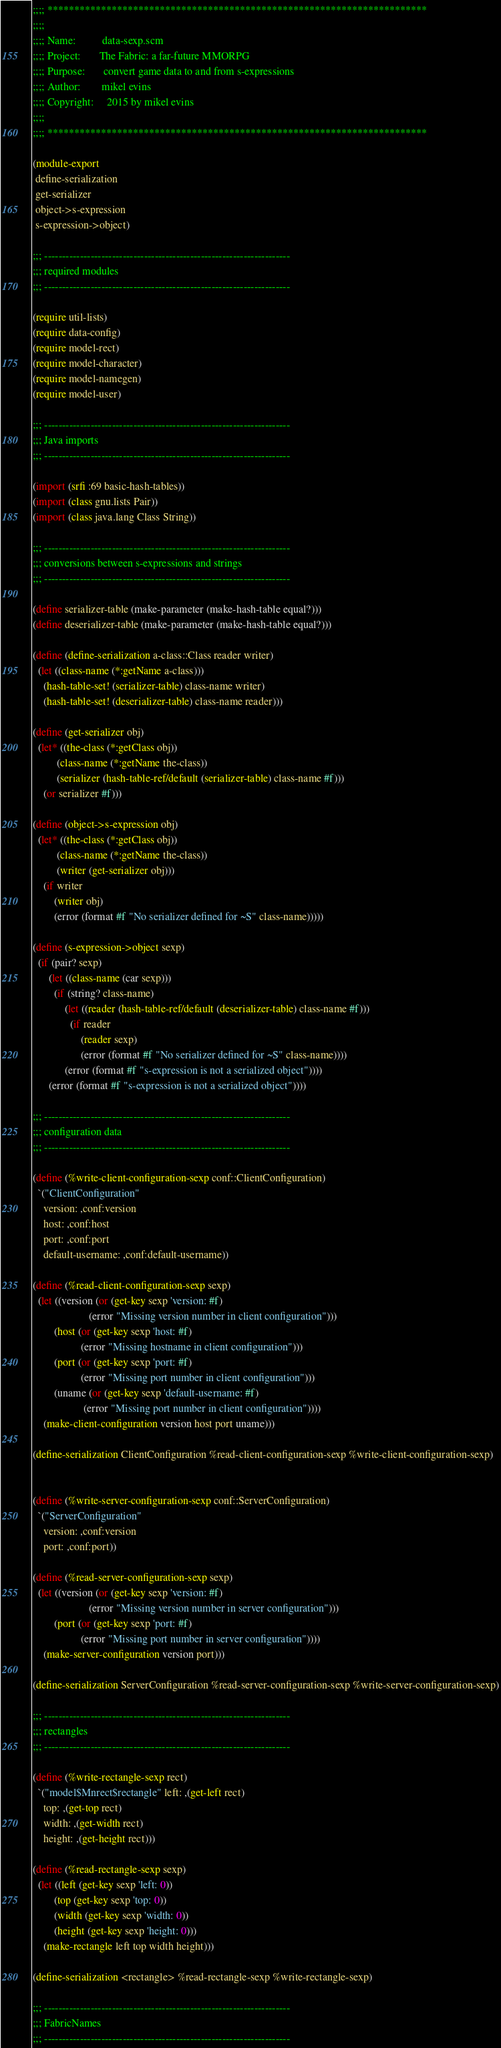Convert code to text. <code><loc_0><loc_0><loc_500><loc_500><_Scheme_>;;;; ***********************************************************************
;;;;
;;;; Name:          data-sexp.scm
;;;; Project:       The Fabric: a far-future MMORPG
;;;; Purpose:       convert game data to and from s-expressions
;;;; Author:        mikel evins
;;;; Copyright:     2015 by mikel evins
;;;;
;;;; ***********************************************************************

(module-export
 define-serialization
 get-serializer
 object->s-expression
 s-expression->object)

;;; ---------------------------------------------------------------------
;;; required modules
;;; ---------------------------------------------------------------------

(require util-lists)
(require data-config)
(require model-rect)
(require model-character)
(require model-namegen)
(require model-user)

;;; ---------------------------------------------------------------------
;;; Java imports
;;; ---------------------------------------------------------------------

(import (srfi :69 basic-hash-tables))
(import (class gnu.lists Pair))
(import (class java.lang Class String))

;;; ---------------------------------------------------------------------
;;; conversions between s-expressions and strings
;;; ---------------------------------------------------------------------

(define serializer-table (make-parameter (make-hash-table equal?)))
(define deserializer-table (make-parameter (make-hash-table equal?)))

(define (define-serialization a-class::Class reader writer)
  (let ((class-name (*:getName a-class)))
    (hash-table-set! (serializer-table) class-name writer)
    (hash-table-set! (deserializer-table) class-name reader)))

(define (get-serializer obj)
  (let* ((the-class (*:getClass obj))
         (class-name (*:getName the-class))
         (serializer (hash-table-ref/default (serializer-table) class-name #f)))
    (or serializer #f)))

(define (object->s-expression obj)
  (let* ((the-class (*:getClass obj))
         (class-name (*:getName the-class))
         (writer (get-serializer obj)))
    (if writer
        (writer obj)
        (error (format #f "No serializer defined for ~S" class-name)))))

(define (s-expression->object sexp)
  (if (pair? sexp)
      (let ((class-name (car sexp)))
        (if (string? class-name)
            (let ((reader (hash-table-ref/default (deserializer-table) class-name #f)))
              (if reader
                  (reader sexp)
                  (error (format #f "No serializer defined for ~S" class-name))))
            (error (format #f "s-expression is not a serialized object"))))
      (error (format #f "s-expression is not a serialized object"))))

;;; ---------------------------------------------------------------------
;;; configuration data
;;; ---------------------------------------------------------------------

(define (%write-client-configuration-sexp conf::ClientConfiguration)
  `("ClientConfiguration"
    version: ,conf:version
    host: ,conf:host
    port: ,conf:port
    default-username: ,conf:default-username))

(define (%read-client-configuration-sexp sexp)
  (let ((version (or (get-key sexp 'version: #f)
                     (error "Missing version number in client configuration")))
        (host (or (get-key sexp 'host: #f)
                  (error "Missing hostname in client configuration")))
        (port (or (get-key sexp 'port: #f)
                  (error "Missing port number in client configuration")))
        (uname (or (get-key sexp 'default-username: #f)
                   (error "Missing port number in client configuration"))))
    (make-client-configuration version host port uname)))

(define-serialization ClientConfiguration %read-client-configuration-sexp %write-client-configuration-sexp)


(define (%write-server-configuration-sexp conf::ServerConfiguration)
  `("ServerConfiguration"
    version: ,conf:version
    port: ,conf:port))

(define (%read-server-configuration-sexp sexp)
  (let ((version (or (get-key sexp 'version: #f)
                     (error "Missing version number in server configuration")))
        (port (or (get-key sexp 'port: #f)
                  (error "Missing port number in server configuration"))))
    (make-server-configuration version port)))

(define-serialization ServerConfiguration %read-server-configuration-sexp %write-server-configuration-sexp)

;;; ---------------------------------------------------------------------
;;; rectangles
;;; ---------------------------------------------------------------------

(define (%write-rectangle-sexp rect)
  `("model$Mnrect$rectangle" left: ,(get-left rect)
    top: ,(get-top rect)
    width: ,(get-width rect)
    height: ,(get-height rect)))

(define (%read-rectangle-sexp sexp)
  (let ((left (get-key sexp 'left: 0))
        (top (get-key sexp 'top: 0))
        (width (get-key sexp 'width: 0))
        (height (get-key sexp 'height: 0)))
    (make-rectangle left top width height)))

(define-serialization <rectangle> %read-rectangle-sexp %write-rectangle-sexp)

;;; ---------------------------------------------------------------------
;;; FabricNames
;;; ---------------------------------------------------------------------

</code> 